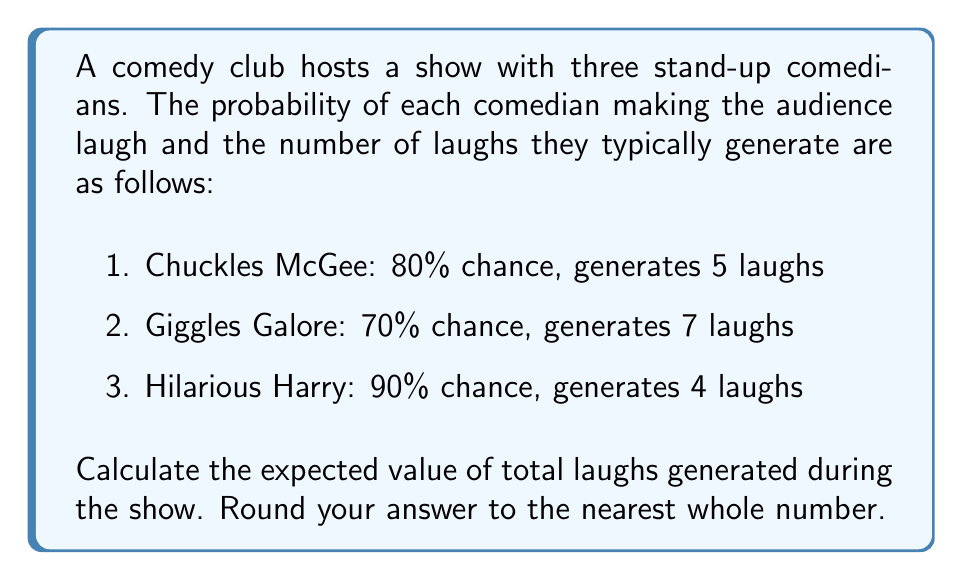Can you answer this question? To calculate the expected value of laughs, we need to:

1. Calculate the expected laughs for each comedian
2. Sum up the expected laughs for all comedians

For each comedian:
Expected laughs = Probability of making audience laugh × Number of laughs generated

1. Chuckles McGee:
   $E(\text{Chuckles}) = 0.80 \times 5 = 4$ laughs

2. Giggles Galore:
   $E(\text{Giggles}) = 0.70 \times 7 = 4.9$ laughs

3. Hilarious Harry:
   $E(\text{Harry}) = 0.90 \times 4 = 3.6$ laughs

Total expected laughs:
$$E(\text{Total}) = E(\text{Chuckles}) + E(\text{Giggles}) + E(\text{Harry})$$
$$E(\text{Total}) = 4 + 4.9 + 3.6 = 12.5$$

Rounding to the nearest whole number: 13 laughs
Answer: 13 laughs 